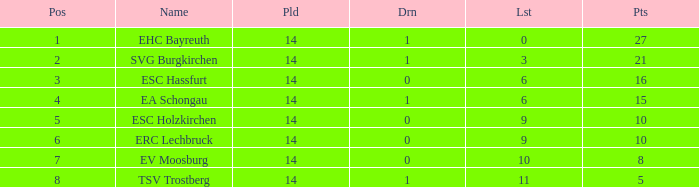What's the lost when there were more than 16 points and had a drawn less than 1? None. 